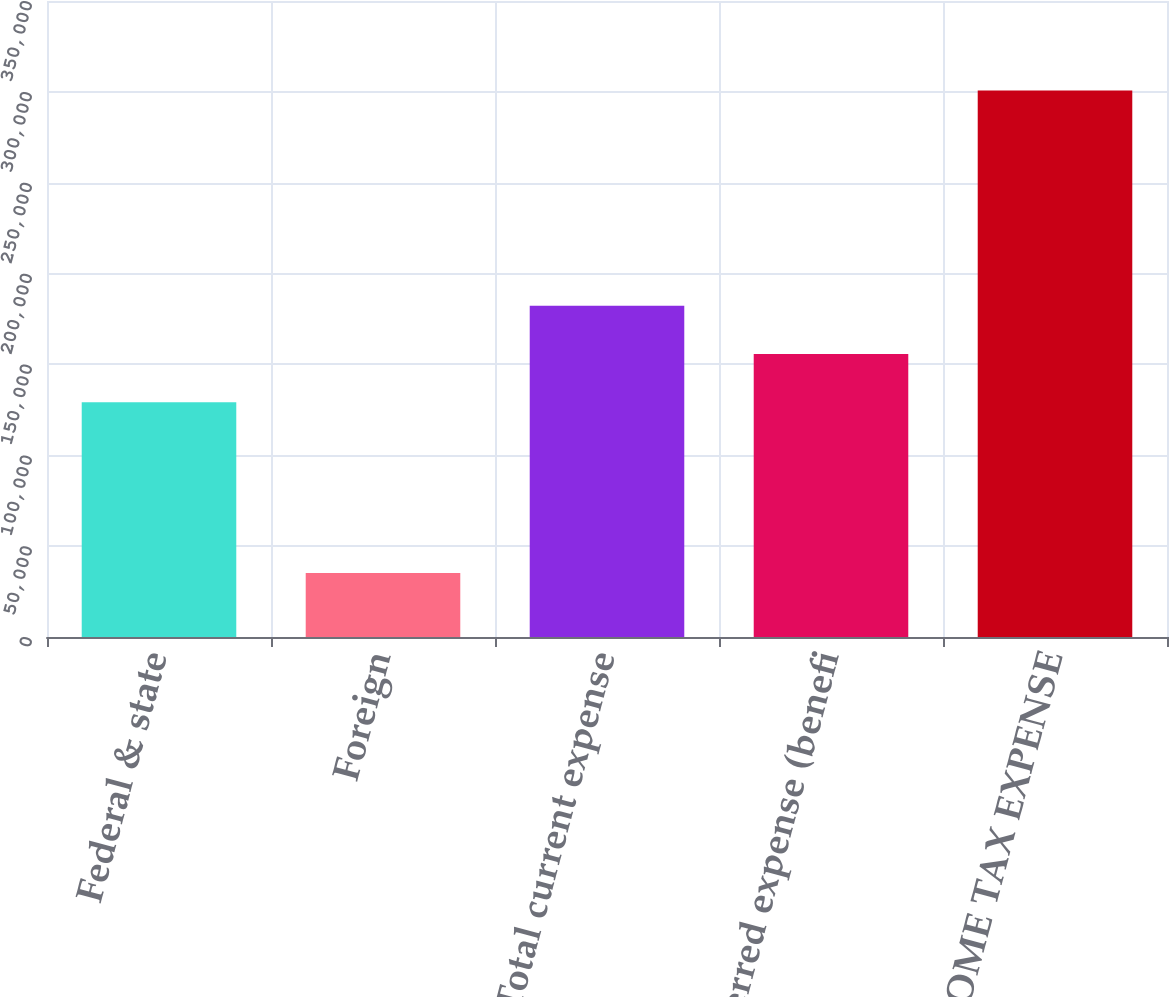<chart> <loc_0><loc_0><loc_500><loc_500><bar_chart><fcel>Federal & state<fcel>Foreign<fcel>Total current expense<fcel>Total deferred expense (benefi<fcel>TOTAL INCOME TAX EXPENSE<nl><fcel>129204<fcel>35188<fcel>182325<fcel>155764<fcel>300792<nl></chart> 